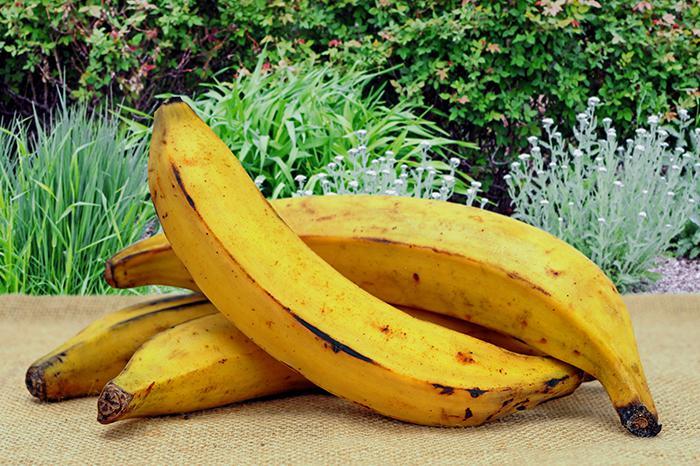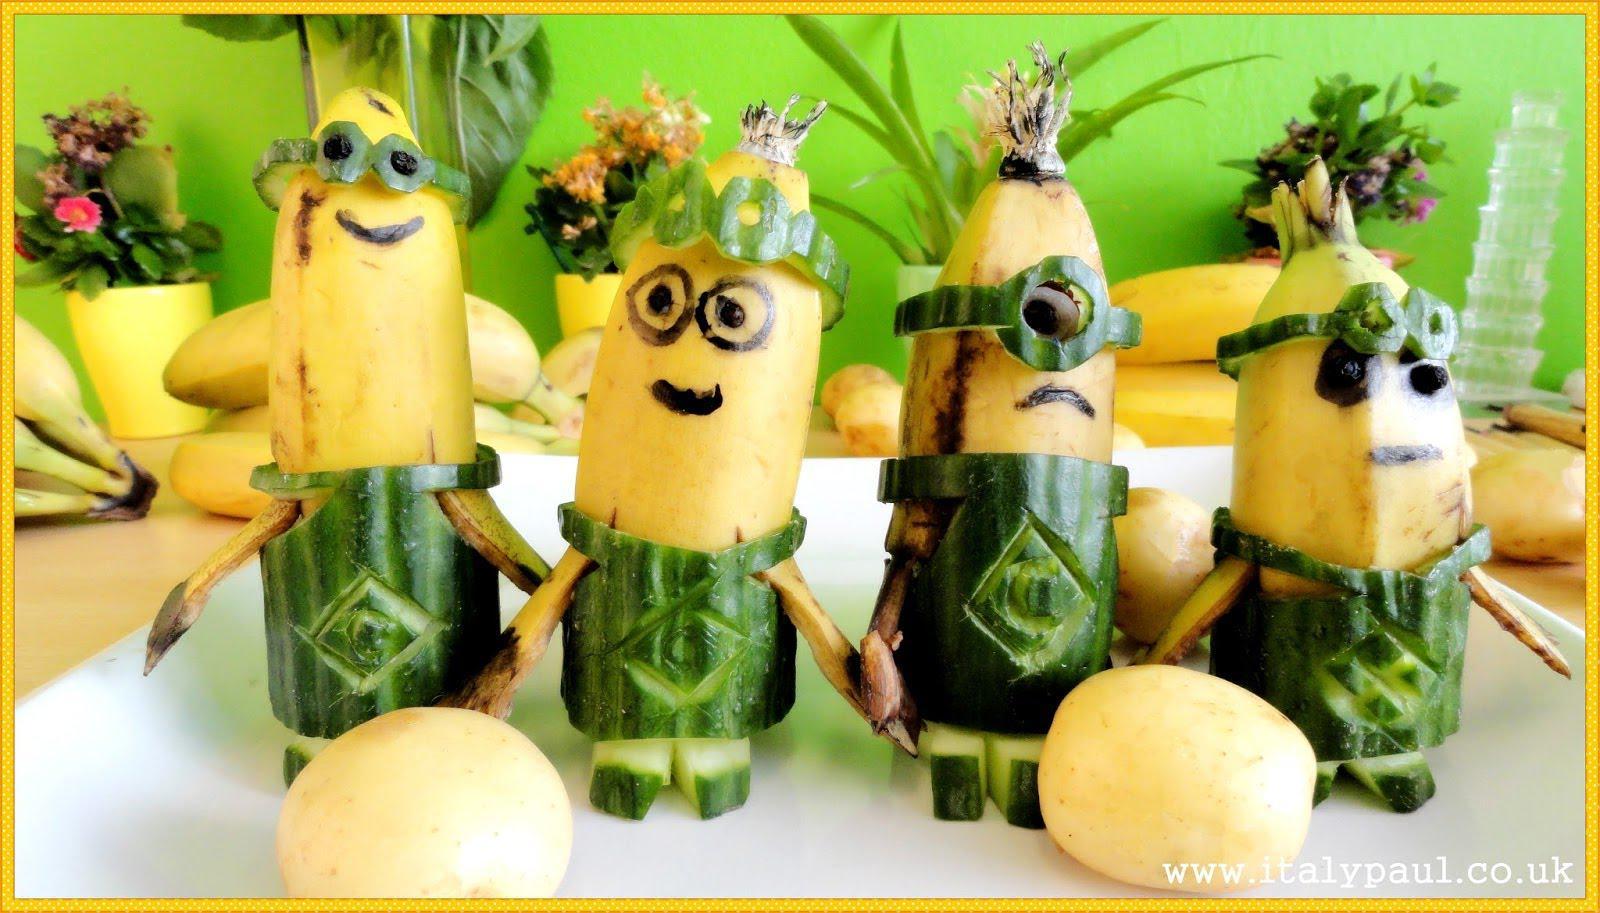The first image is the image on the left, the second image is the image on the right. For the images shown, is this caption "All the bananas in the right image are in a bunch." true? Answer yes or no. No. The first image is the image on the left, the second image is the image on the right. Examine the images to the left and right. Is the description "In at least one image there is a single attached group of bananas." accurate? Answer yes or no. No. 